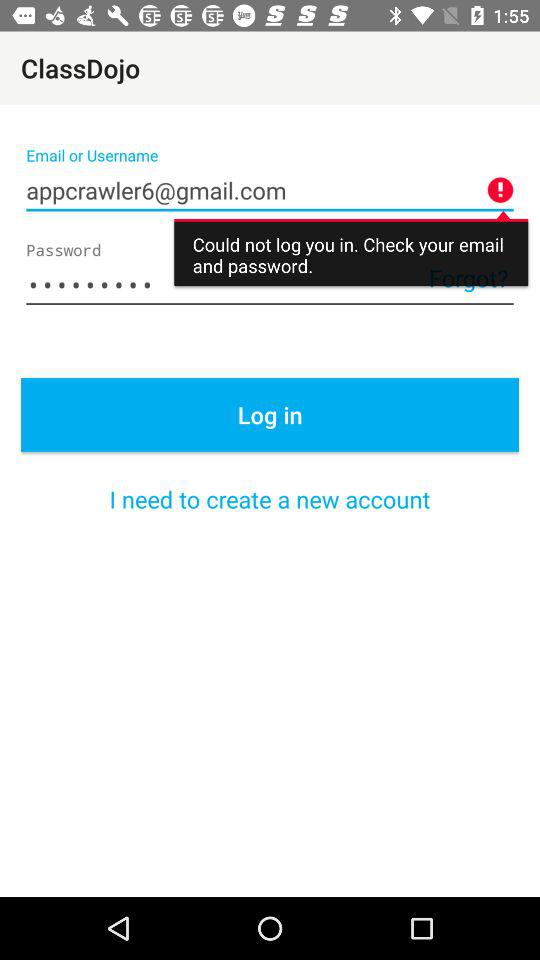What are the requirements to get a log-in? The requirements are "Email or Username" and "Password". 